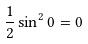Convert formula to latex. <formula><loc_0><loc_0><loc_500><loc_500>\frac { 1 } { 2 } \sin ^ { 2 } 0 = 0</formula> 